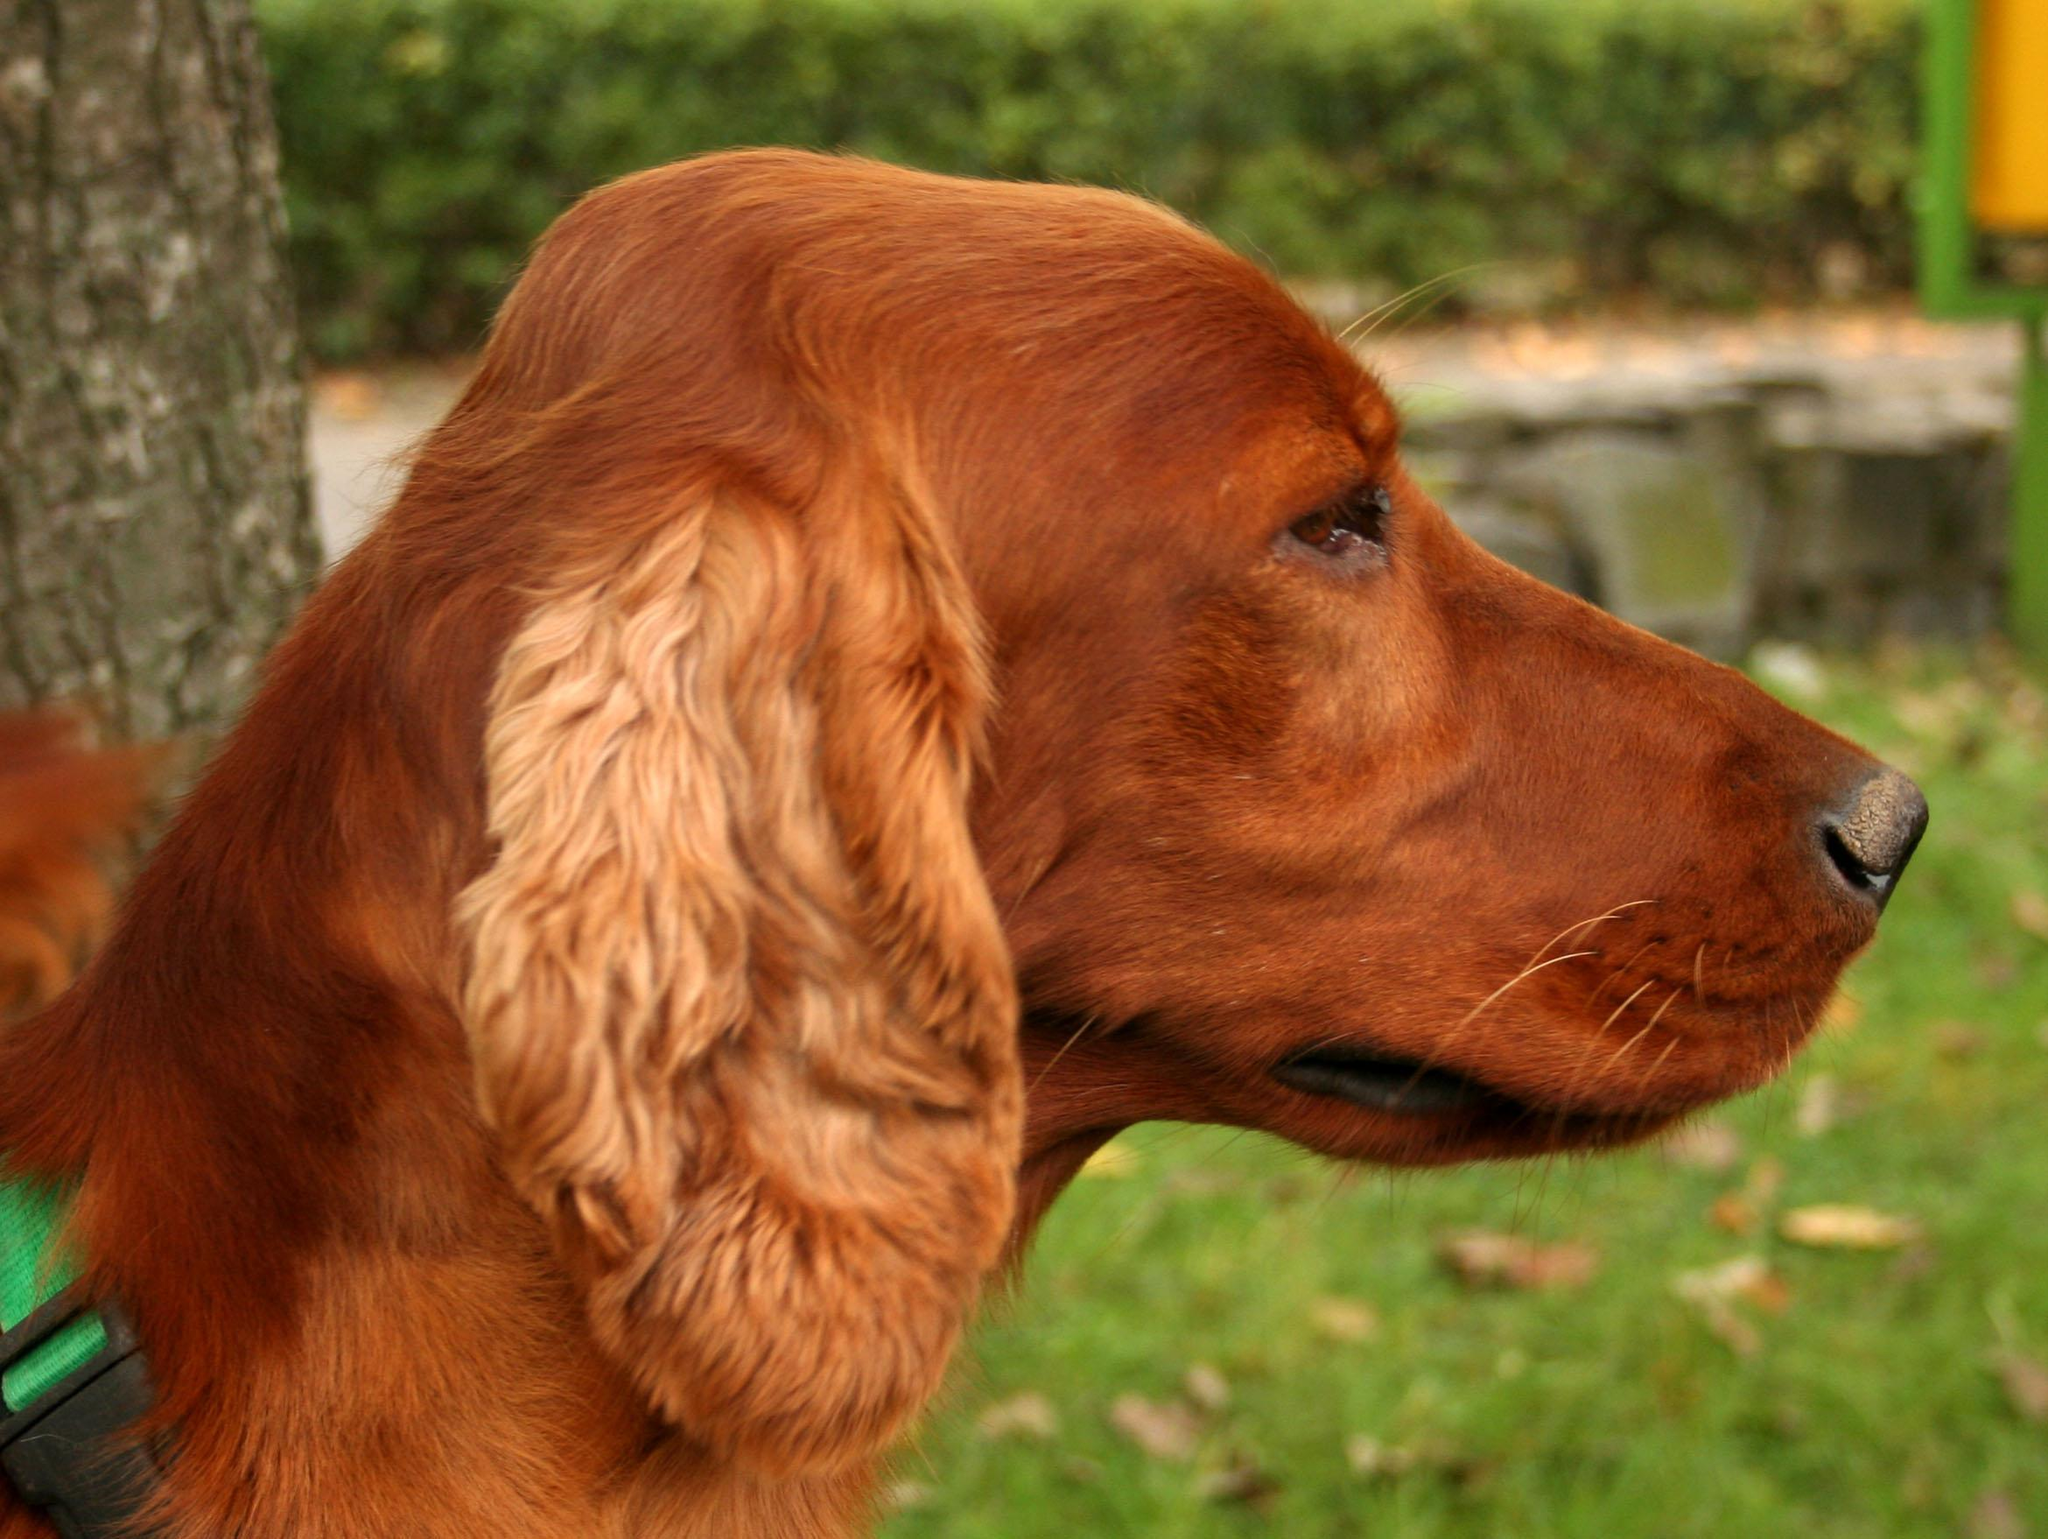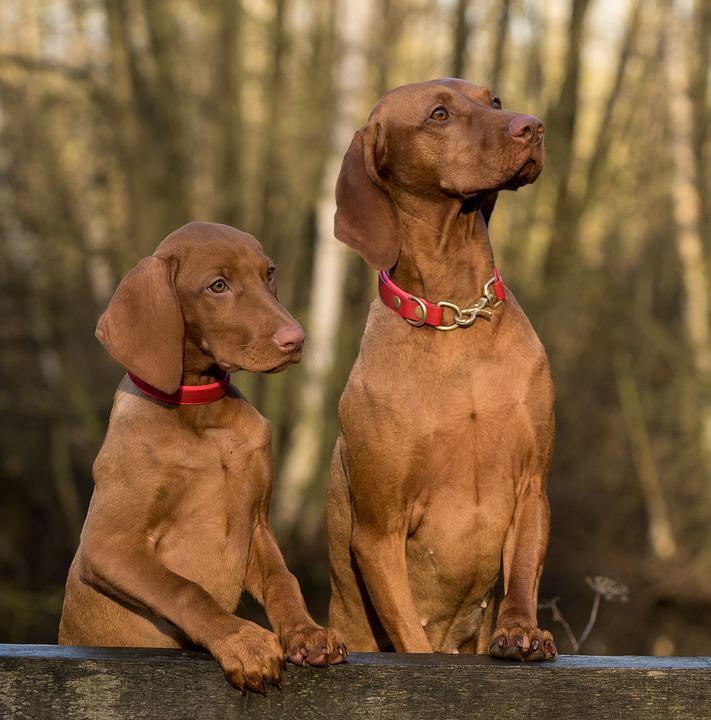The first image is the image on the left, the second image is the image on the right. Considering the images on both sides, is "There are two dogs in one image and one dog in the other image." valid? Answer yes or no. Yes. The first image is the image on the left, the second image is the image on the right. Evaluate the accuracy of this statement regarding the images: "One dog's forehead is scrunched up.". Is it true? Answer yes or no. No. 